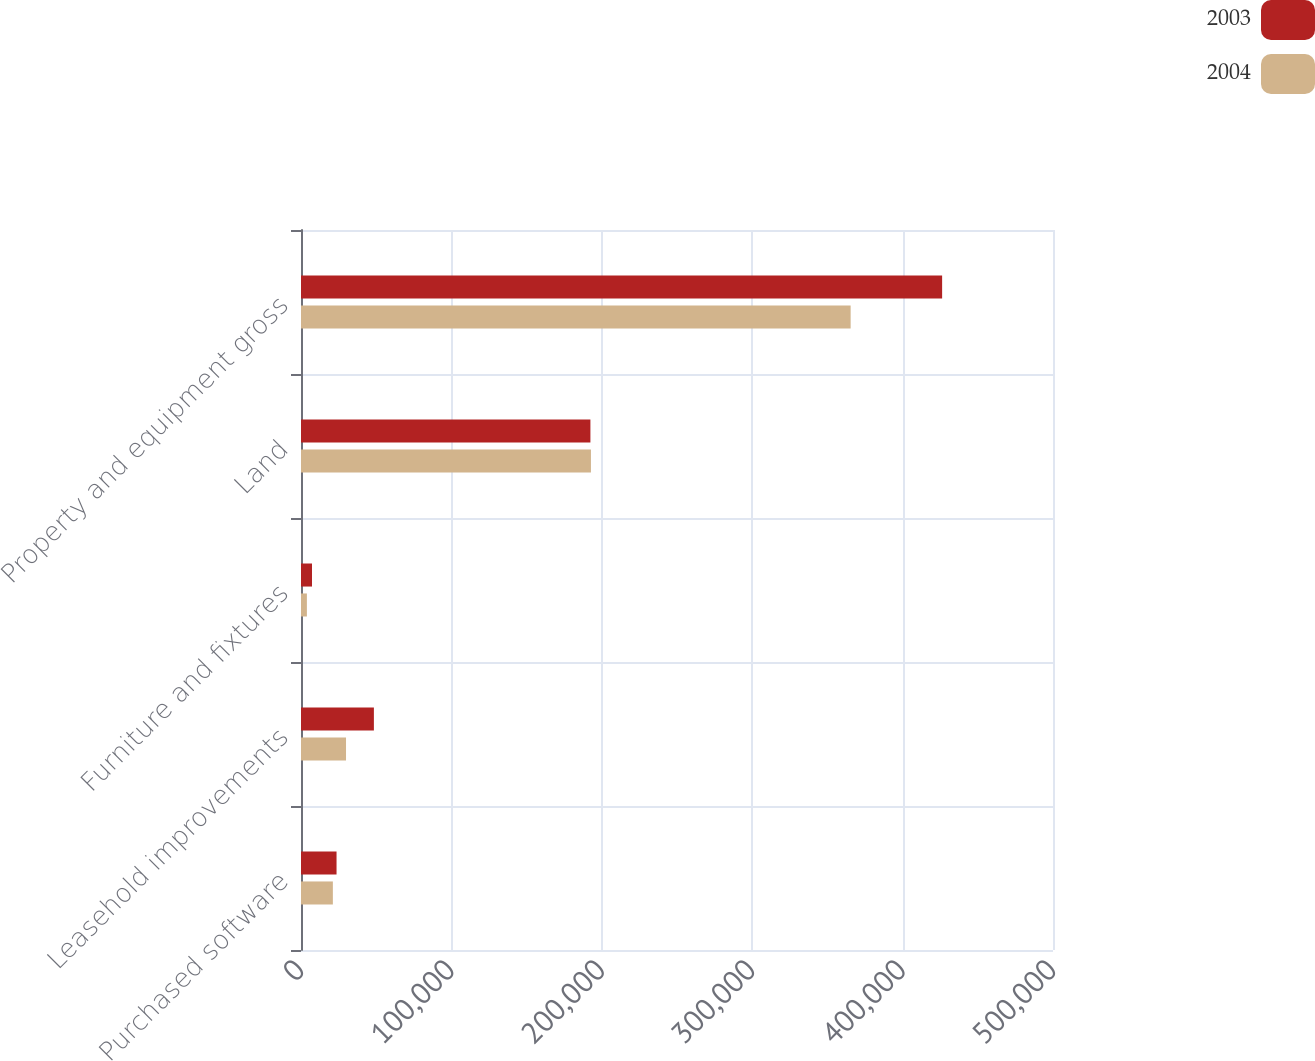Convert chart. <chart><loc_0><loc_0><loc_500><loc_500><stacked_bar_chart><ecel><fcel>Purchased software<fcel>Leasehold improvements<fcel>Furniture and fixtures<fcel>Land<fcel>Property and equipment gross<nl><fcel>2003<fcel>23633<fcel>48467<fcel>7315<fcel>192427<fcel>426281<nl><fcel>2004<fcel>21190<fcel>29935<fcel>3920<fcel>192778<fcel>365455<nl></chart> 